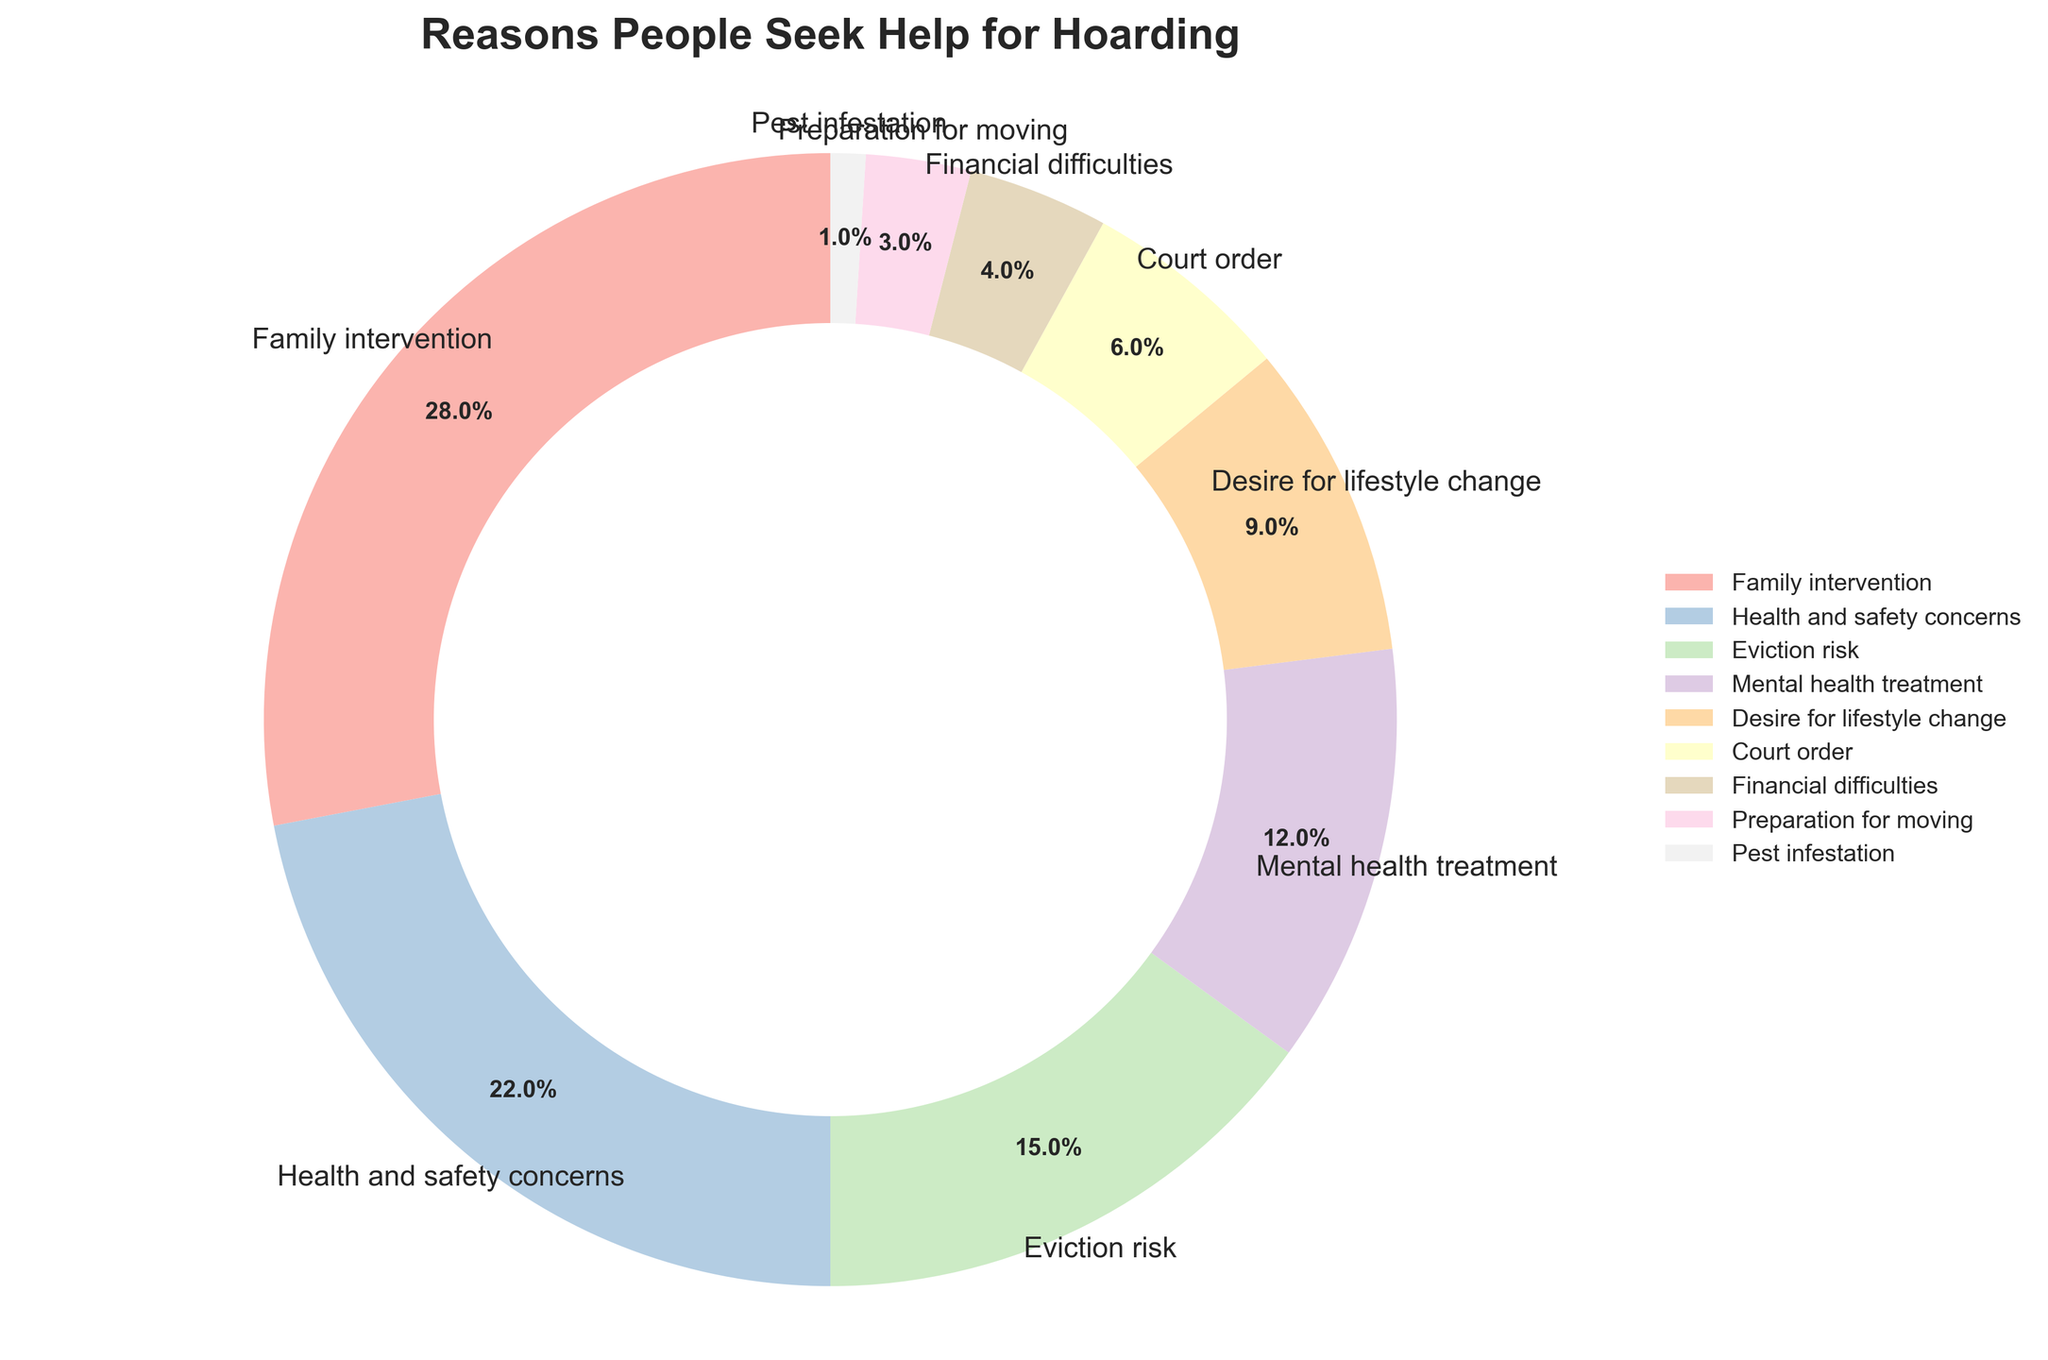What is the most common reason people seek help for hoarding? The most common reason is the one with the highest percentage shown in the pie chart. According to the chart, "Family intervention" has the highest percentage at 28%.
Answer: Family intervention How much greater is the percentage for "Family intervention" compared to "Court order"? First, identify the percentages: Family intervention is 28%, and Court order is 6%. Then, subtract the percentage for Court Order from that of Family Intervention, which is 28 - 6 = 22%.
Answer: 22% What two reasons combined account for half of the reasons people seek help for hoarding? To determine which two reasons combined make up around 50%, look for pairs that sum to approximately 50%. "Family intervention" (28%) and "Health and safety concerns" (22%) add up to 50%.
Answer: Family intervention and Health and safety concerns Which reason is represented by the smallest slice in the pie chart? The smallest slice on the chart corresponds to the reason with the smallest percentage. According to the data, "Pest infestation" has the smallest percentage at 1%.
Answer: Pest infestation What is the angle difference between "Eviction risk" and "Desire for lifestyle change"? Each full slice (360 degrees) in a pie chart corresponds to 100%; hence, each percentage is equivalent to 3.6 degrees (360/100). For "Eviction risk" (15%) and "Desire for lifestyle change" (9%), convert to angles: 15% * 3.6 = 54 degrees and 9% * 3.6 = 32.4 degrees. The angle difference is 54 - 32.4 = 21.6 degrees.
Answer: 21.6 degrees Rank the reasons people seek help for hoarding from highest to lowest percentage. List the reasons in descending order based on their percentages: Family intervention (28%), Health and safety concerns (22%), Eviction risk (15%), Mental health treatment (12%), Desire for lifestyle change (9%), Court order (6%), Financial difficulties (4%), Preparation for moving (3%), Pest infestation (1%).
Answer: Family intervention, Health and safety concerns, Eviction risk, Mental health treatment, Desire for lifestyle change, Court order, Financial difficulties, Preparation for moving, Pest infestation How many reasons have a percentage greater than 10%? Identify and count all reasons with percentages higher than 10%. These are: Family intervention (28%), Health and safety concerns (22%), Eviction risk (15%), and Mental health treatment (12%). There are 4 such reasons.
Answer: 4 Is "Desire for lifestyle change" more or less common than "Mental health treatment"? Compare their percentages directly from the pie chart: Desire for lifestyle change has 9%, while Mental health treatment has 12%. Thus, Desire for lifestyle change is less common.
Answer: Less common What is the combined percentage of reasons that have less than 5%? Look for reasons with percentages below 5%: Financial difficulties (4%), Preparation for moving (3%), and Pest infestation (1%). Add them up: 4 + 3 + 1 = 8%.
Answer: 8% 